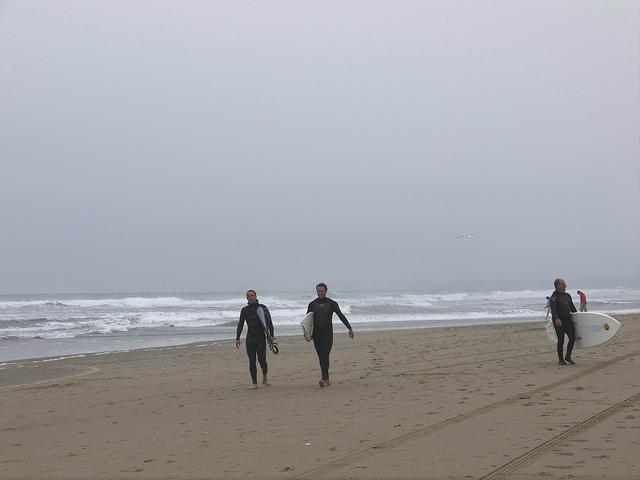Are there any other surfers around?
Write a very short answer. Yes. Are these people standing on the beach?
Give a very brief answer. Yes. How many horses are on the beach?
Give a very brief answer. 0. What are the people doing?
Be succinct. Walking. How many people do you see in this picture?
Be succinct. 4. Are those prints in the sand from human feet?
Short answer required. Yes. What sport are the guys playing?
Concise answer only. Surfing. Is the person alone?
Be succinct. No. Is it cold where this girl is?
Quick response, please. Yes. What is the man looking at?
Quick response, please. Camera. Are there a lot of waves?
Keep it brief. Yes. Are there people swimming?
Quick response, please. No. How many people can be seen?
Concise answer only. 4. How many different activities are people in the picture engaged in?
Keep it brief. 1. What are they on?
Answer briefly. Beach. 